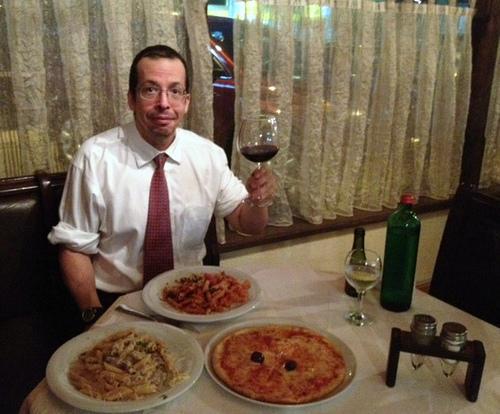How many dishes are there?
Give a very brief answer. 3. 